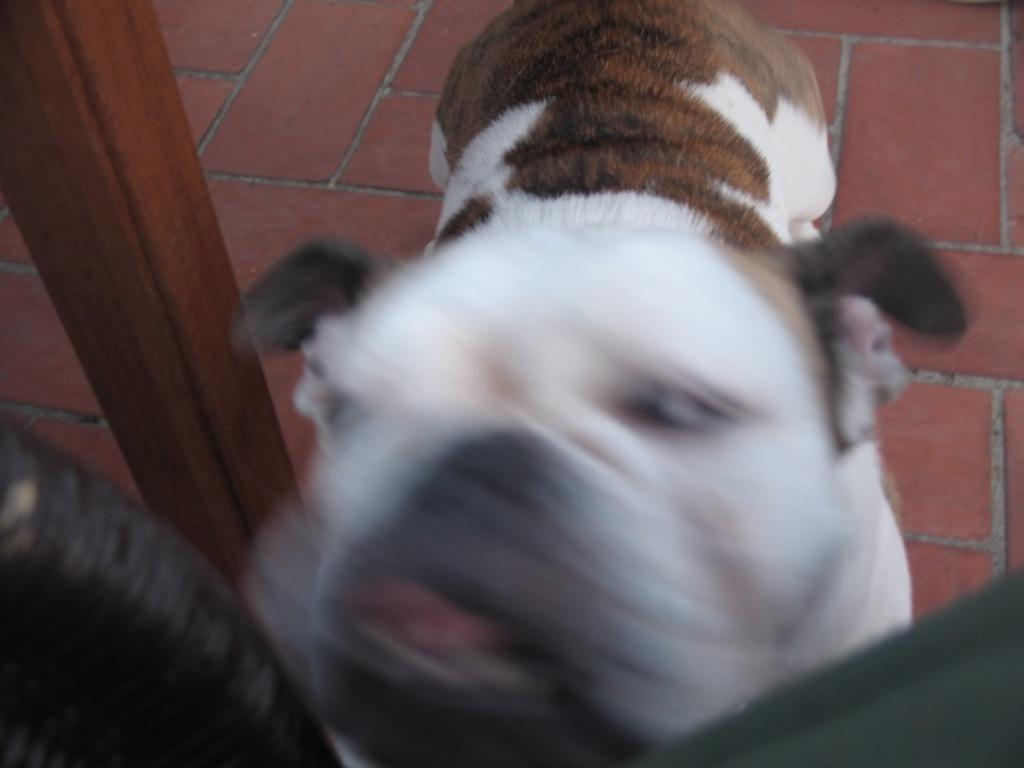What type of animal is in the image? There is a dog in the image. Can you describe the dog's appearance? The dog is white and brown in color. What is at the bottom of the image? There is a floor at the bottom of the image. What can be seen on the left side of the image? There is a wooden pillar on the left side of the image. What type of marble is the dog playing with in the image? There is no marble present in the image, and the dog is not playing with any object. What trick is the dog performing in the image? The image does not depict the dog performing any tricks. 